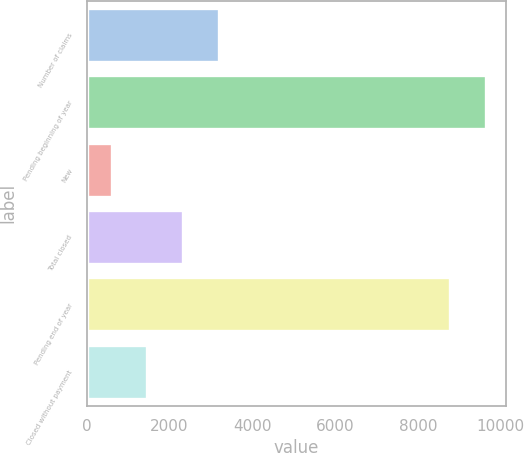Convert chart to OTSL. <chart><loc_0><loc_0><loc_500><loc_500><bar_chart><fcel>Number of claims<fcel>Pending beginning of year<fcel>New<fcel>Total closed<fcel>Pending end of year<fcel>Closed without payment<nl><fcel>3197.5<fcel>9645.5<fcel>601<fcel>2332<fcel>8780<fcel>1466.5<nl></chart> 